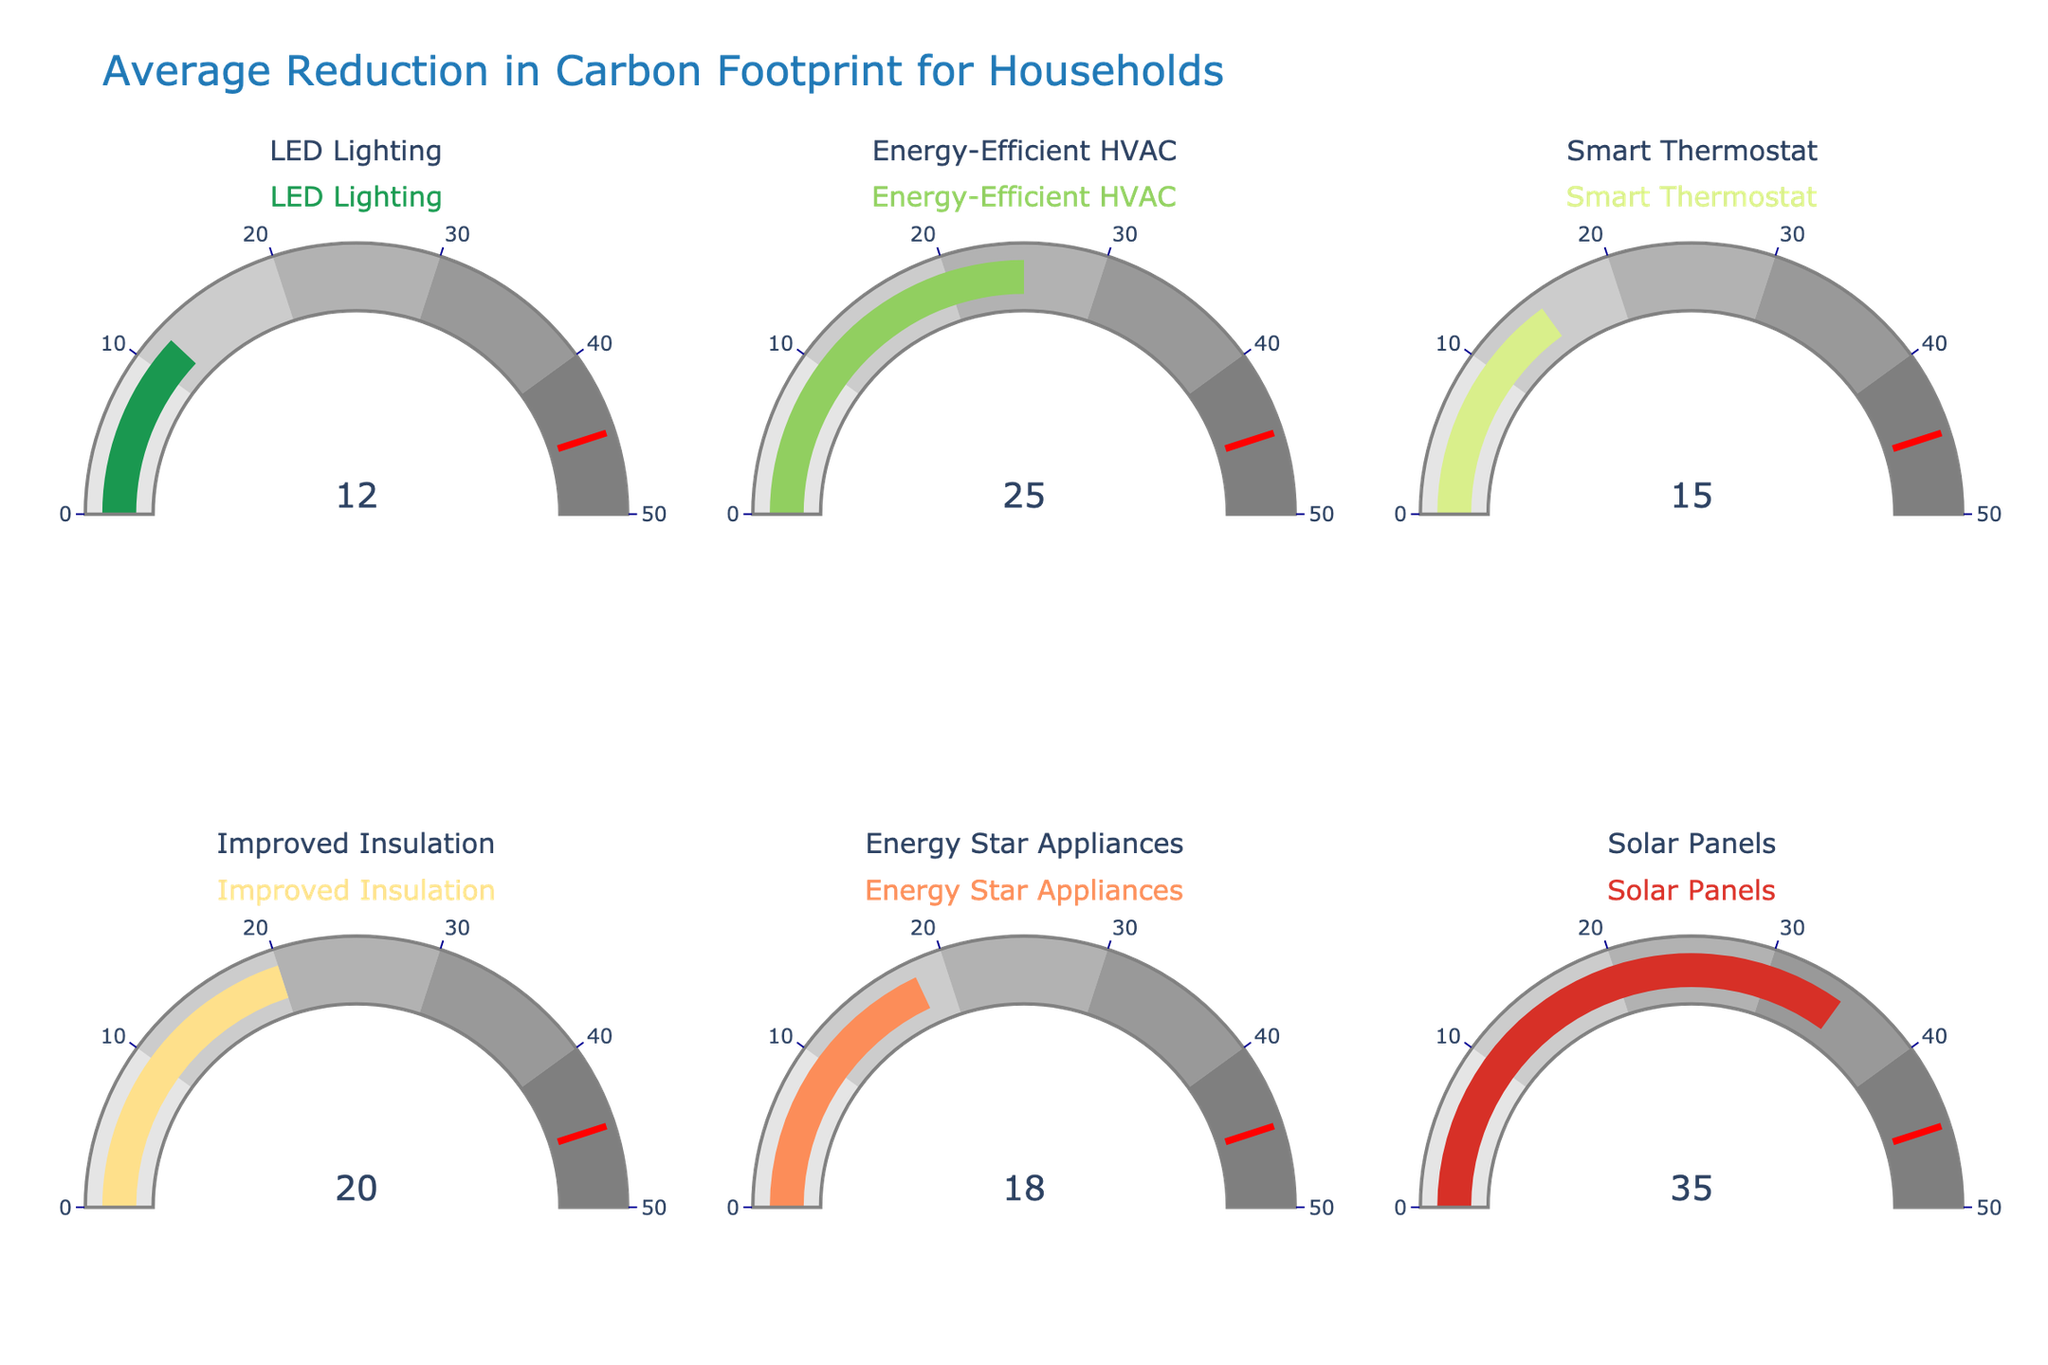Which energy-efficient update shows the highest average reduction in carbon footprint? The gauge for Solar Panels shows the highest average reduction at 35%. Comparing the values for all updates, Solar Panels have the highest percentage.
Answer: Solar Panels What is the average reduction percentage for Energy Star Appliances? The Energy Star Appliances gauge displays a value indicating a 18% average reduction in carbon footprint.
Answer: 18% What is the difference in average reduction between Energy-Efficient HVAC and Improved Insulation? Energy-Efficient HVAC has a 25% reduction while Improved Insulation has a 20% reduction. The difference is calculated as 25% - 20% = 5%.
Answer: 5% Which update has a higher average reduction: Smart Thermostat or LED Lighting? The Smart Thermostat gauge shows a 15% reduction, while the LED Lighting gauge shows a 12% reduction. Smart Thermostat is higher.
Answer: Smart Thermostat What’s the total combined average reduction in carbon footprint for LED Lighting, Smart Thermostats, and Energy Star Appliances? The reductions are 12% for LED Lighting, 15% for Smart Thermostats, and 18% for Energy Star Appliances. Adding these gives 12 + 15 + 18 = 45%.
Answer: 45% If we exclude Solar Panels, what is the average reduction percentage of the remaining updates? Excluding Solar Panels, the reductions are 12%, 25%, 15%, 20%, and 18%. The average is calculated as (12 + 25 + 15 + 20 + 18) / 5 = 18%.
Answer: 18% What's the second-highest average reduction in carbon footprint? The gauge for Solar Panels shows the highest reduction at 35%. The second-highest is Energy-Efficient HVAC with a 25% reduction.
Answer: Energy-Efficient HVAC Which gauge shows a reduction closer to 20% and what is the exact value? Improved Insulation's gauge is closest to 20%, which is also the exact value displayed on its gauge.
Answer: Improved Insulation, 20% Between Energy-Efficient HVAC and Energy Star Appliances, which has a greater reduction in carbon footprint and by how much? Energy-Efficient HVAC has a 25% reduction, while Energy Star Appliances has an 18% reduction. The difference is 25% - 18% = 7%.
Answer: Energy-Efficient HVAC, 7% What is the median value of the average reductions displayed in the gauges? The values are 12%, 25%, 15%, 20%, 18%, and 35%. Arranging these in ascending order: 12%, 15%, 18%, 20%, 25%, 35%. The median value (middle value) for an even number of entries is the average of the two central numbers: (18% + 20%) / 2 = 19%.
Answer: 19% 